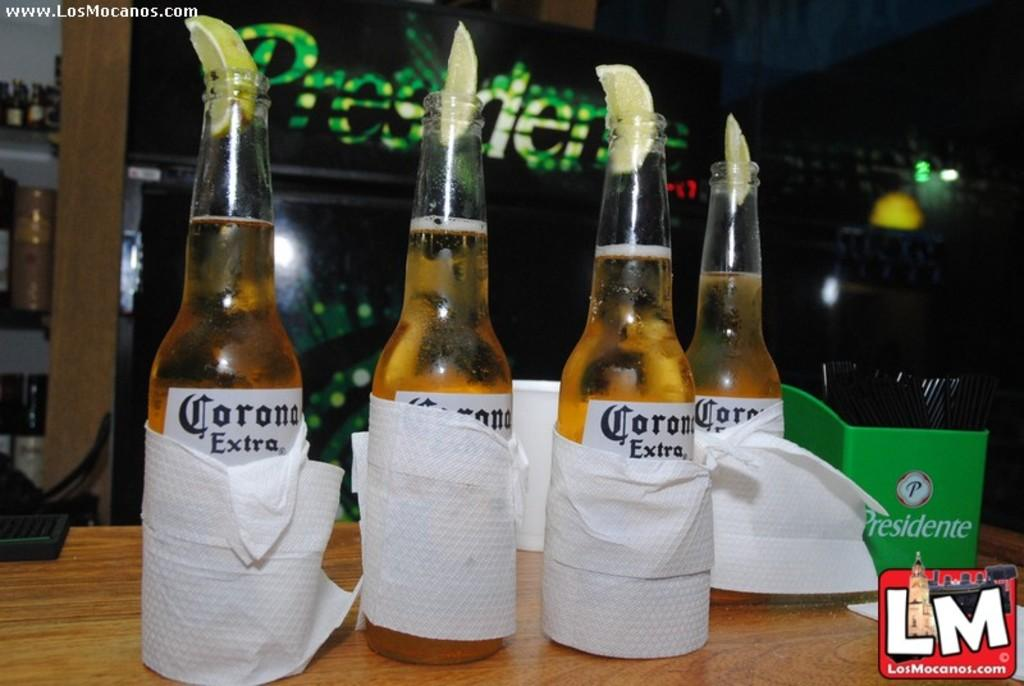<image>
Summarize the visual content of the image. Several bottles of Corona Extra are wrapped with white cloths. 